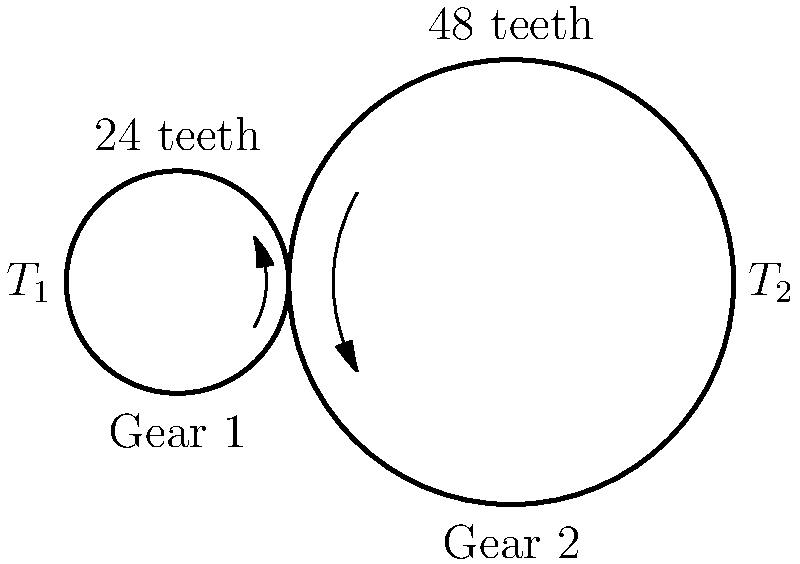In a simple gear train used in a secure communication device, Gear 1 has 24 teeth and Gear 2 has 48 teeth. If the input torque $T_1$ applied to Gear 1 is 50 N·m, what is the output torque $T_2$ on Gear 2? Assume the system is 100% efficient and there are no losses due to friction. To solve this problem, we'll follow these steps:

1. Calculate the gear ratio:
   The gear ratio is the ratio of the number of teeth on the output gear to the number of teeth on the input gear.
   Gear ratio = $\frac{\text{Teeth on Gear 2}}{\text{Teeth on Gear 1}} = \frac{48}{24} = 2$

2. Understand the relationship between gear ratio, angular velocity, and torque:
   In a gear train, the product of torque and angular velocity is constant (assuming 100% efficiency).
   $T_1 \omega_1 = T_2 \omega_2$, where $\omega$ is the angular velocity.

3. Express the gear ratio in terms of angular velocities:
   Gear ratio = $\frac{\omega_1}{\omega_2} = 2$

4. Use the torque-angular velocity relationship:
   $T_1 \omega_1 = T_2 \frac{\omega_1}{2}$

5. Simplify and solve for $T_2$:
   $T_2 = 2T_1 = 2 \times 50\text{ N·m} = 100\text{ N·m}$

Therefore, the output torque $T_2$ on Gear 2 is 100 N·m.
Answer: 100 N·m 